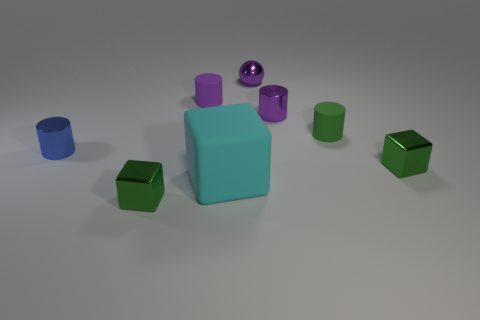Are there any repeating patterns or themes in the image? Yes, there is a repeating theme of geometric shapes, specifically cubes and cylinders. Additionally, there is a pattern in the coloration with variations of matte and shiny textures. 